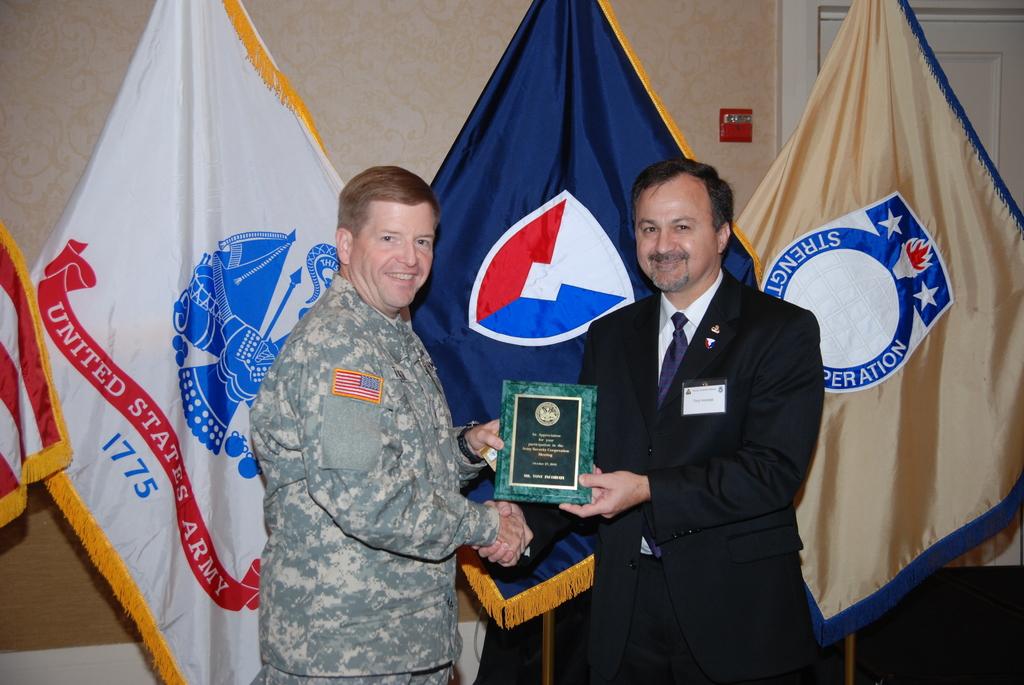What year is listed on the flag?
Provide a succinct answer. 1775. What does it say on the red portion of the falg above the year?
Provide a short and direct response. United states army. 